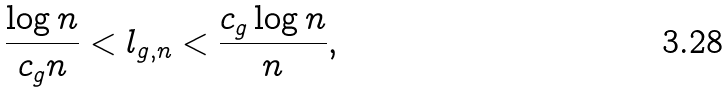<formula> <loc_0><loc_0><loc_500><loc_500>\frac { \log n } { c _ { g } n } < l _ { g , n } < \frac { c _ { g } \log n } { n } ,</formula> 